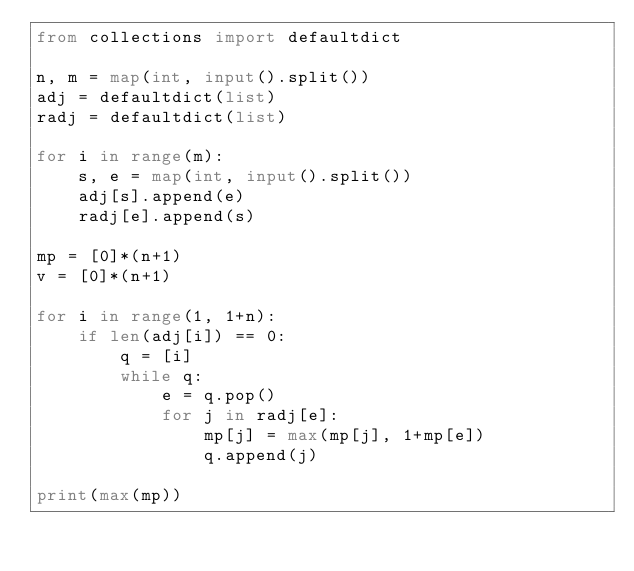Convert code to text. <code><loc_0><loc_0><loc_500><loc_500><_Python_>from collections import defaultdict
    
n, m = map(int, input().split())
adj = defaultdict(list)
radj = defaultdict(list)

for i in range(m):
    s, e = map(int, input().split())
    adj[s].append(e)
    radj[e].append(s)
    
mp = [0]*(n+1)
v = [0]*(n+1)
    
for i in range(1, 1+n):
    if len(adj[i]) == 0:
        q = [i]
        while q:
            e = q.pop()
            for j in radj[e]:
                mp[j] = max(mp[j], 1+mp[e])
                q.append(j)

print(max(mp))</code> 